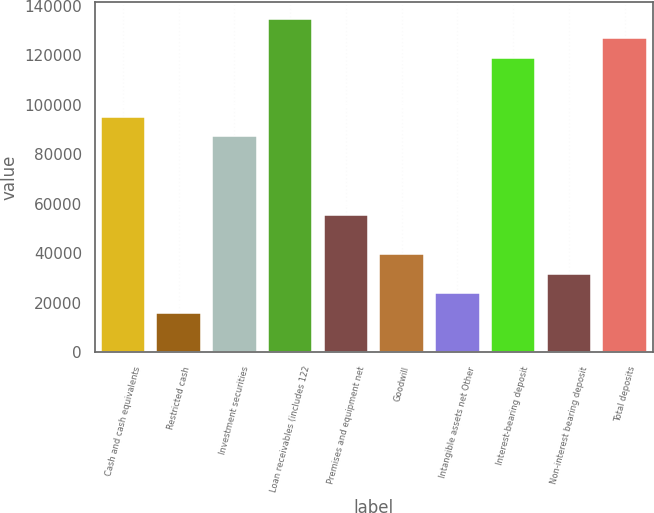Convert chart to OTSL. <chart><loc_0><loc_0><loc_500><loc_500><bar_chart><fcel>Cash and cash equivalents<fcel>Restricted cash<fcel>Investment securities<fcel>Loan receivables (includes 122<fcel>Premises and equipment net<fcel>Goodwill<fcel>Intangible assets net Other<fcel>Interest-bearing deposit<fcel>Non-interest bearing deposit<fcel>Total deposits<nl><fcel>95207<fcel>15872<fcel>87273.5<fcel>134874<fcel>55539.5<fcel>39672.5<fcel>23805.5<fcel>119008<fcel>31739<fcel>126941<nl></chart> 